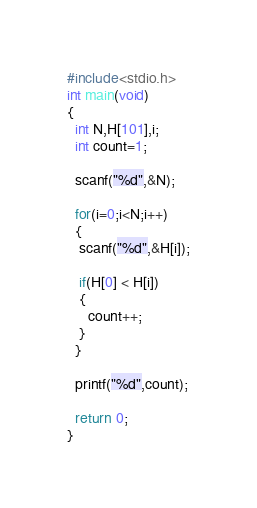<code> <loc_0><loc_0><loc_500><loc_500><_C_>#include<stdio.h>
int main(void)
{
  int N,H[101],i;
  int count=1;
  
  scanf("%d",&N);
  
  for(i=0;i<N;i++)
  {
   scanf("%d",&H[i]);

   if(H[0] < H[i])
   {
     count++;
   }
  }

  printf("%d",count);
  
  return 0;
}
</code> 